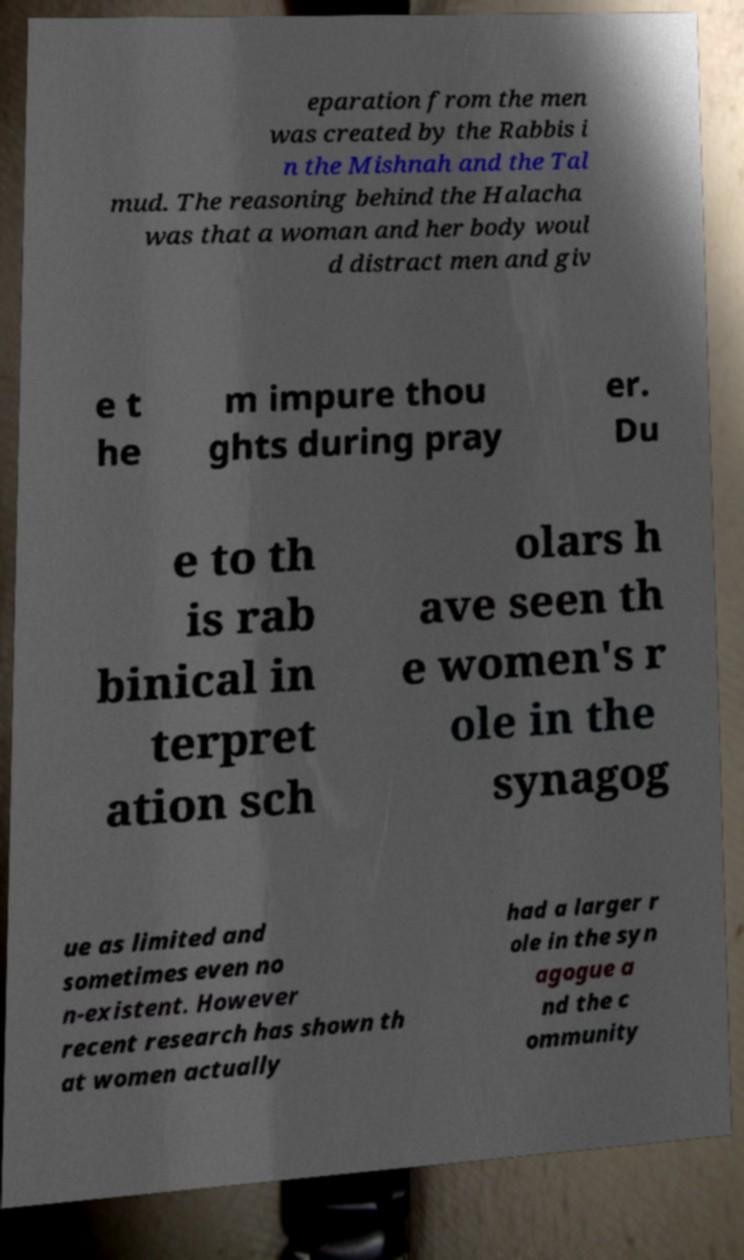Can you accurately transcribe the text from the provided image for me? eparation from the men was created by the Rabbis i n the Mishnah and the Tal mud. The reasoning behind the Halacha was that a woman and her body woul d distract men and giv e t he m impure thou ghts during pray er. Du e to th is rab binical in terpret ation sch olars h ave seen th e women's r ole in the synagog ue as limited and sometimes even no n-existent. However recent research has shown th at women actually had a larger r ole in the syn agogue a nd the c ommunity 